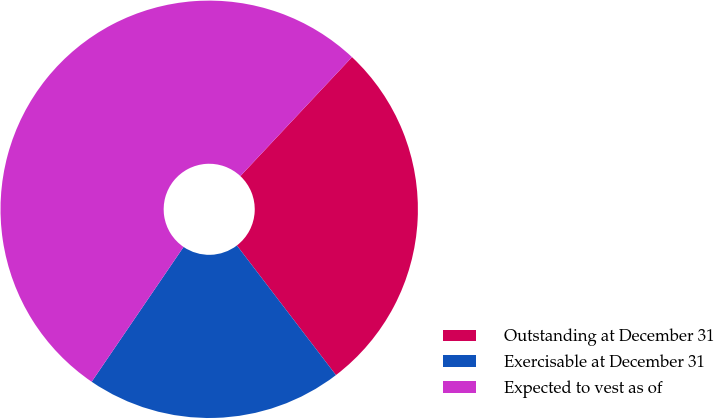Convert chart to OTSL. <chart><loc_0><loc_0><loc_500><loc_500><pie_chart><fcel>Outstanding at December 31<fcel>Exercisable at December 31<fcel>Expected to vest as of<nl><fcel>27.62%<fcel>19.91%<fcel>52.47%<nl></chart> 